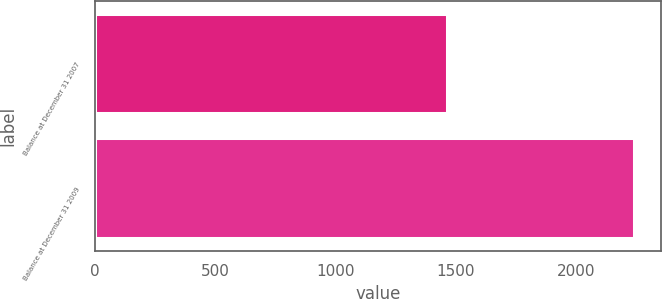<chart> <loc_0><loc_0><loc_500><loc_500><bar_chart><fcel>Balance at December 31 2007<fcel>Balance at December 31 2009<nl><fcel>1462<fcel>2240<nl></chart> 